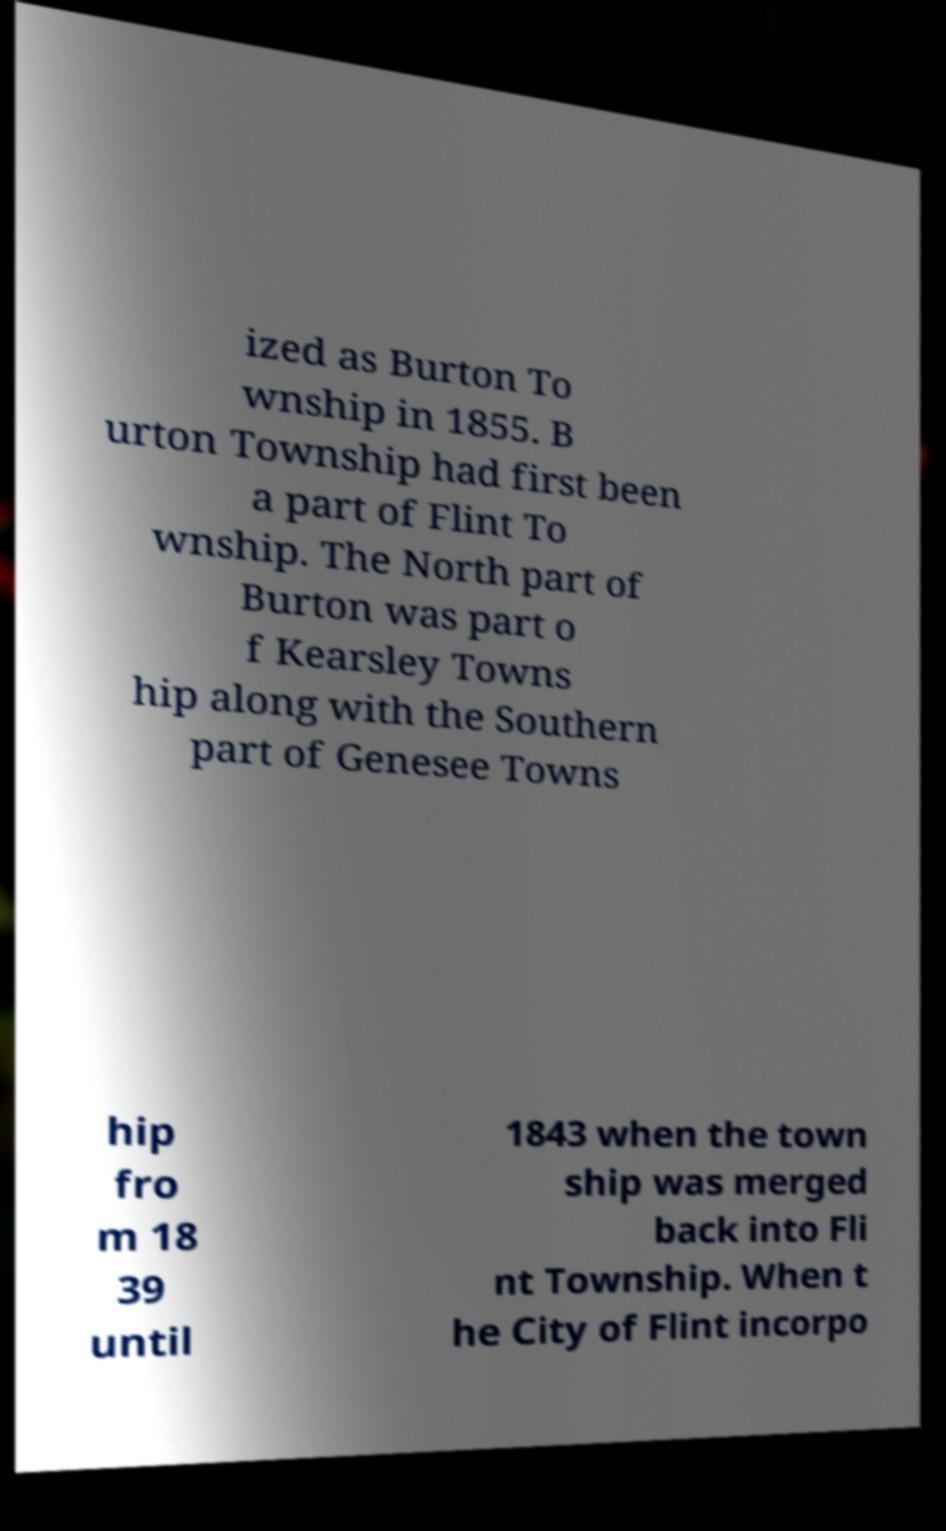For documentation purposes, I need the text within this image transcribed. Could you provide that? ized as Burton To wnship in 1855. B urton Township had first been a part of Flint To wnship. The North part of Burton was part o f Kearsley Towns hip along with the Southern part of Genesee Towns hip fro m 18 39 until 1843 when the town ship was merged back into Fli nt Township. When t he City of Flint incorpo 